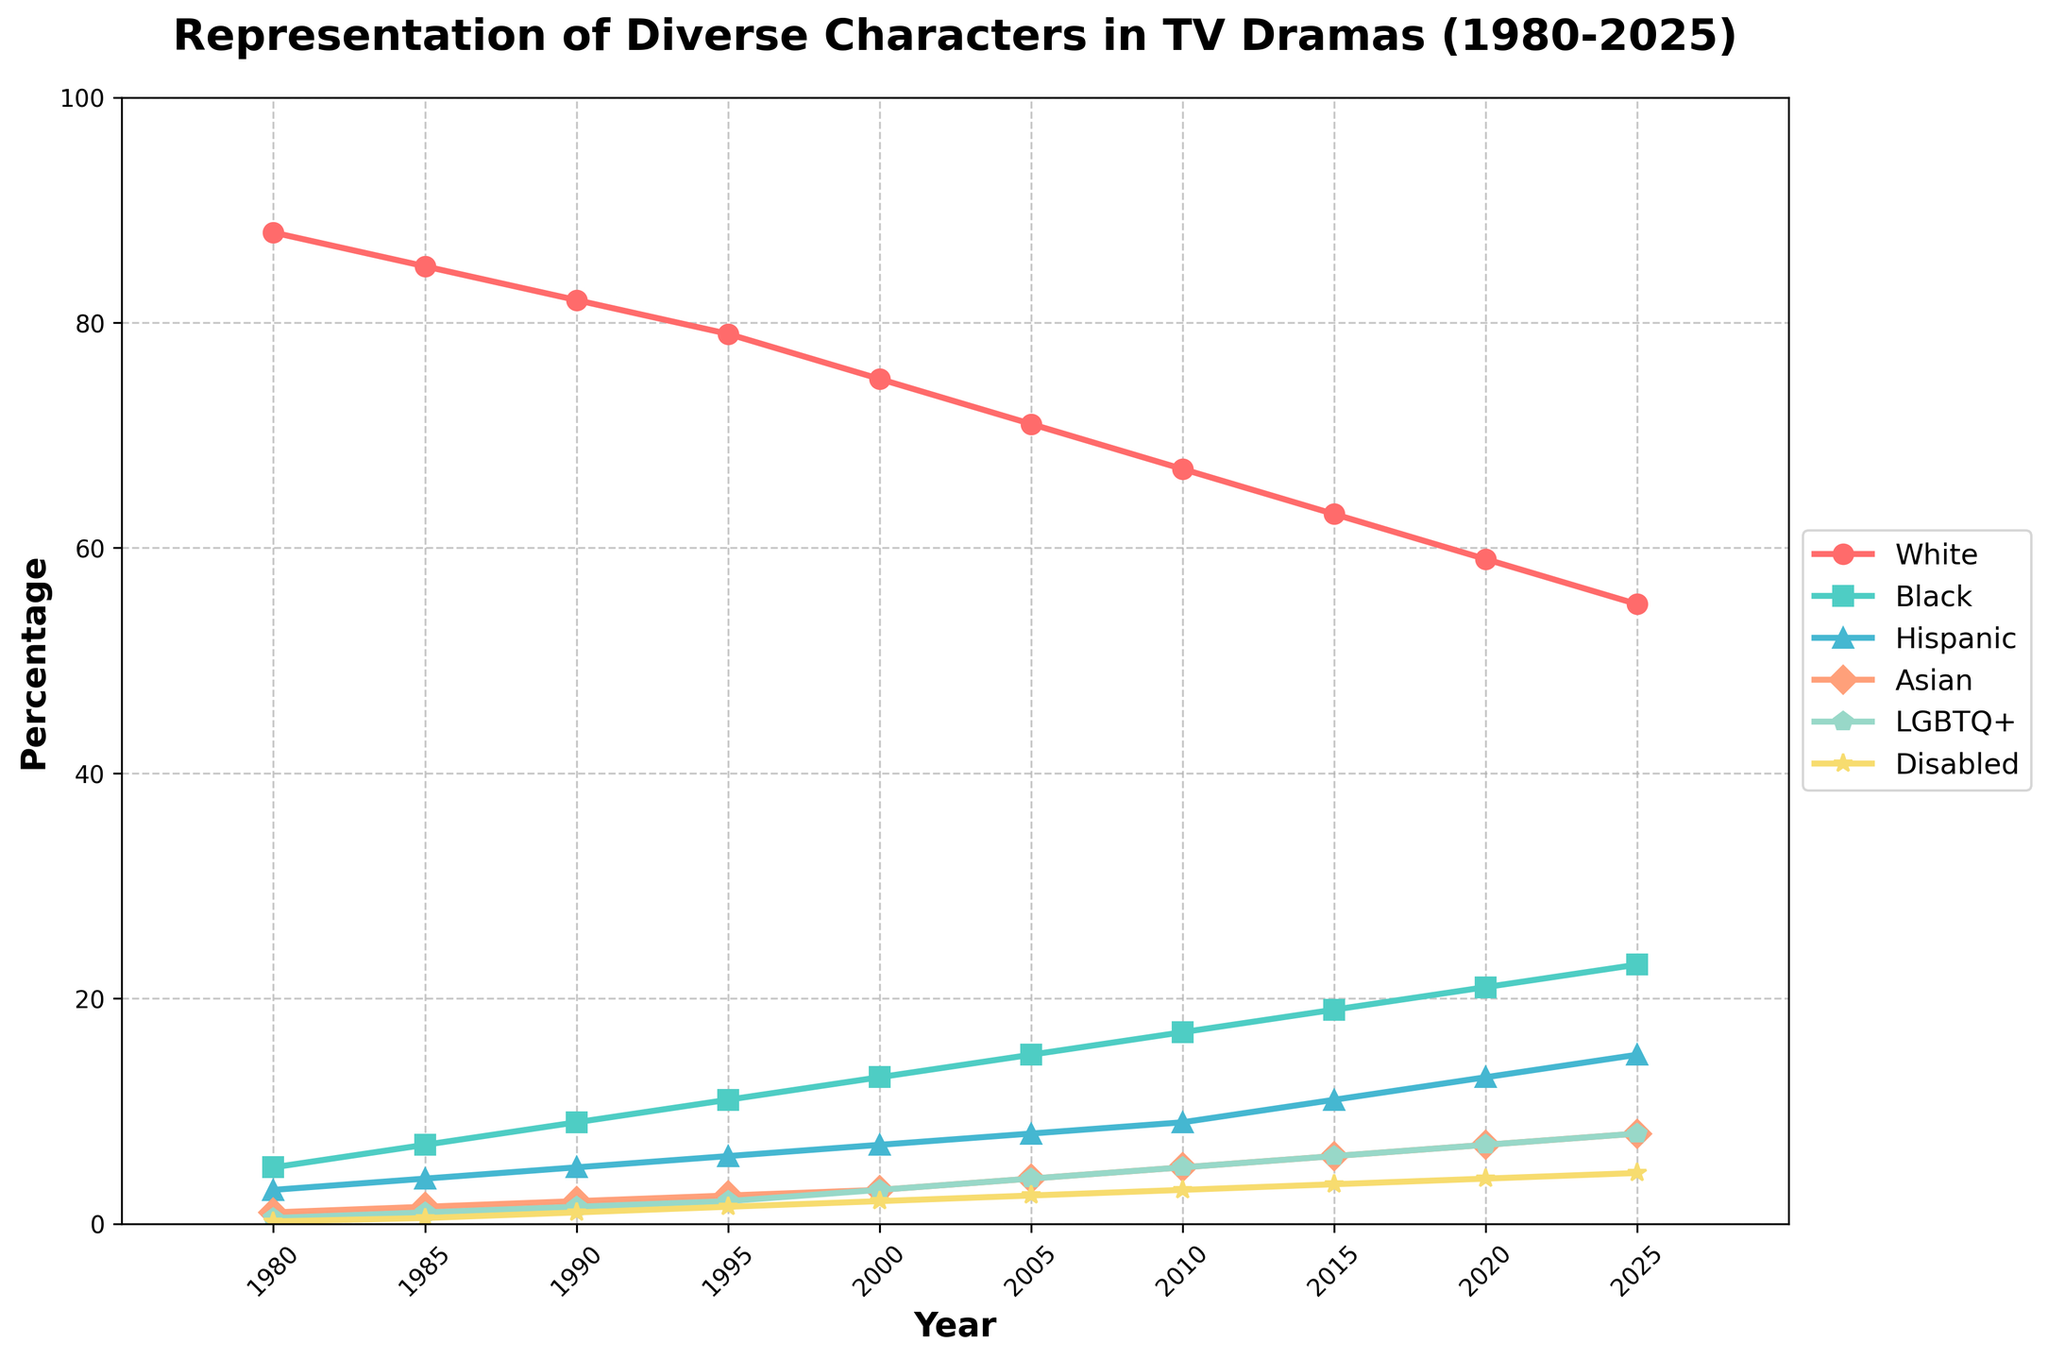What's the percentage increase in representation for Hispanic characters from 1980 to 2025? To find the percentage increase, subtract the 1980 percentage (3) from the 2025 percentage (15). Then, divide the result by the 1980 percentage and multiply by 100: ((15 - 3) / 3) * 100 = 400%
Answer: 400% Comparing the representation of Disabled and LGBTQ+ characters, which group has a higher percentage in 2020? In 2020, the data shows Disabled characters at 4% and LGBTQ+ characters at 7%. Since 7% is greater than 4%, LGBTQ+ characters have a higher representation.
Answer: LGBTQ+ Between which two adjacent time periods did Asian character representation increase the most? To find the largest increase, calculate the difference for each adjacent period. Between 1980 to 1985: 1.5 - 1 = 0.5; 1985 to 1990: 2 - 1.5 = 0.5; ...; 2020 to 2025: 8 - 7 = 1. The largest is from 2000 to 2005: 4 - 3 = 1.
Answer: 2000-2005 How does the percentage of Black characters in 1985 compare to the percentage of Disabled characters in 2015? The percentage of Black characters in 1985 is 7%, and the percentage of Disabled characters in 2015 is 3.5%. Since 7% is greater than 3.5%, the Black characters' percentage in 1985 is higher.
Answer: Higher Which demographic group shows the most consistent increase in representation from 1980 to 2025? By examining the visual and data trends, every group increases over time, but the Asian group consistently shows steady growth, increasing almost linearly from 1% in 1980 to 8% in 2025.
Answer: Asian What is the combined percentage of representation for LGBTQ+ and Disabled characters in 2010? The percentages in 2010 for LGBTQ+ is 5% and for Disabled is 3%. Adding them together: 5% + 3% = 8%.
Answer: 8% In which year did Hispanic characters reach a double-digit percentage for the first time? From the data, we see the first double-digit percentage for Hispanic characters is in 2015, where it reaches 11%.
Answer: 2015 What is the difference in the representation percentage of White characters between 1980 and 2025? The representation percentage of White characters in 1980 is 88%, and in 2025 it is 55%. Subtracting these gives: 88 - 55 = 33%.
Answer: 33% By how many percentage points did the representation of Black characters increase from 1990 to 2010? In 1990, the percentage was 9%, and in 2010 it was 17%. The increase is calculated as 17% - 9% = 8 percentage points.
Answer: 8 Is the representation of any demographic group other than White below 5% for the entire period? If so, which one? By examining the data table year by year, the lowest representation among groups that consistently stays below 5% is Disabled until 2000, but then it exceeds 5%, so no group stays below 5% for the entire period.
Answer: No 